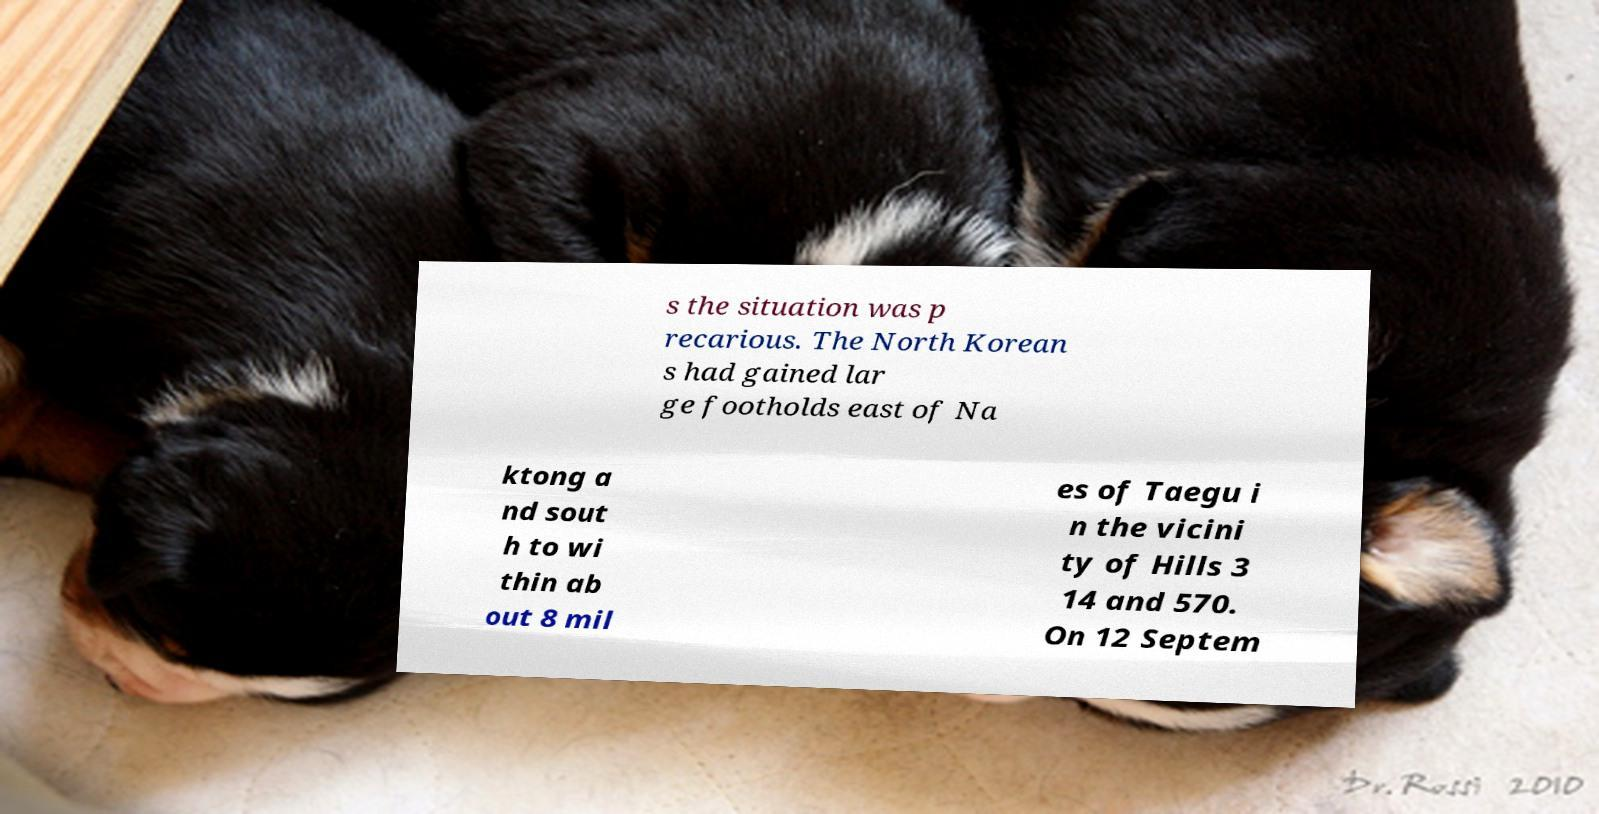Please read and relay the text visible in this image. What does it say? s the situation was p recarious. The North Korean s had gained lar ge footholds east of Na ktong a nd sout h to wi thin ab out 8 mil es of Taegu i n the vicini ty of Hills 3 14 and 570. On 12 Septem 